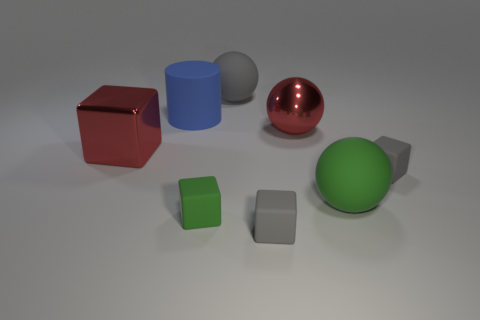Are there any red things made of the same material as the red ball?
Give a very brief answer. Yes. Are there an equal number of large gray spheres that are to the left of the large gray rubber ball and blue things in front of the tiny green object?
Your answer should be compact. Yes. What is the size of the metallic thing right of the big blue rubber cylinder?
Your response must be concise. Large. There is a red object that is left of the matte block in front of the small green matte block; what is it made of?
Your answer should be compact. Metal. What number of tiny gray things are to the left of the red metal thing to the right of the green object left of the gray rubber ball?
Make the answer very short. 1. Do the red object in front of the red metallic ball and the red object that is to the right of the large block have the same material?
Offer a terse response. Yes. What number of other large matte things have the same shape as the big gray rubber object?
Ensure brevity in your answer.  1. Are there more large green balls that are in front of the large blue cylinder than big yellow shiny objects?
Provide a succinct answer. Yes. What is the shape of the gray matte thing that is in front of the gray cube that is on the right side of the matte block in front of the small green cube?
Make the answer very short. Cube. Do the large thing in front of the red cube and the big red thing behind the big red metal block have the same shape?
Offer a very short reply. Yes. 